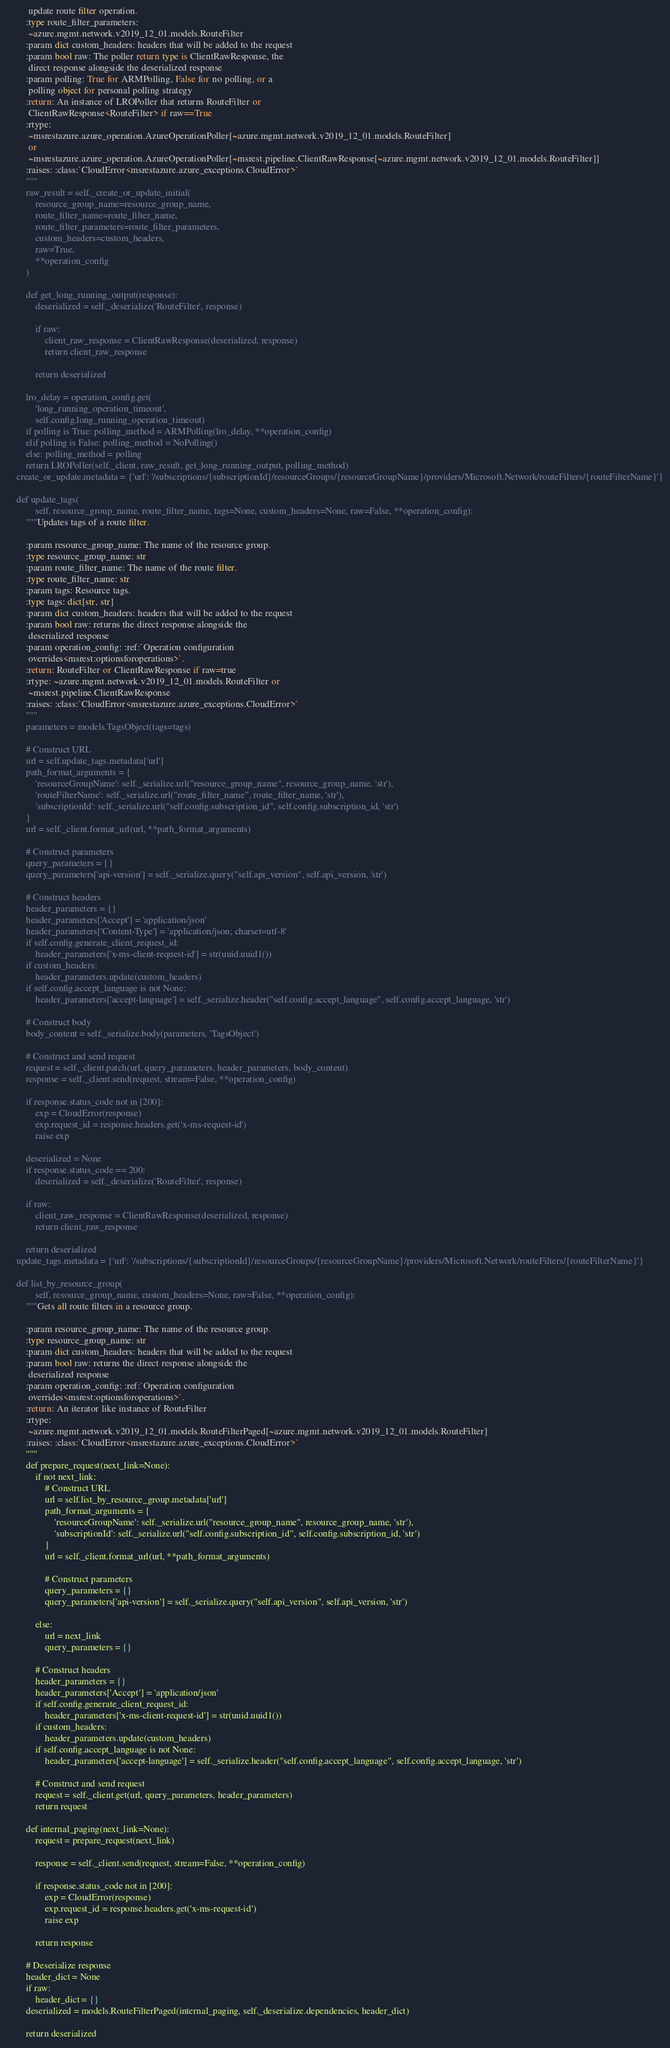<code> <loc_0><loc_0><loc_500><loc_500><_Python_>         update route filter operation.
        :type route_filter_parameters:
         ~azure.mgmt.network.v2019_12_01.models.RouteFilter
        :param dict custom_headers: headers that will be added to the request
        :param bool raw: The poller return type is ClientRawResponse, the
         direct response alongside the deserialized response
        :param polling: True for ARMPolling, False for no polling, or a
         polling object for personal polling strategy
        :return: An instance of LROPoller that returns RouteFilter or
         ClientRawResponse<RouteFilter> if raw==True
        :rtype:
         ~msrestazure.azure_operation.AzureOperationPoller[~azure.mgmt.network.v2019_12_01.models.RouteFilter]
         or
         ~msrestazure.azure_operation.AzureOperationPoller[~msrest.pipeline.ClientRawResponse[~azure.mgmt.network.v2019_12_01.models.RouteFilter]]
        :raises: :class:`CloudError<msrestazure.azure_exceptions.CloudError>`
        """
        raw_result = self._create_or_update_initial(
            resource_group_name=resource_group_name,
            route_filter_name=route_filter_name,
            route_filter_parameters=route_filter_parameters,
            custom_headers=custom_headers,
            raw=True,
            **operation_config
        )

        def get_long_running_output(response):
            deserialized = self._deserialize('RouteFilter', response)

            if raw:
                client_raw_response = ClientRawResponse(deserialized, response)
                return client_raw_response

            return deserialized

        lro_delay = operation_config.get(
            'long_running_operation_timeout',
            self.config.long_running_operation_timeout)
        if polling is True: polling_method = ARMPolling(lro_delay, **operation_config)
        elif polling is False: polling_method = NoPolling()
        else: polling_method = polling
        return LROPoller(self._client, raw_result, get_long_running_output, polling_method)
    create_or_update.metadata = {'url': '/subscriptions/{subscriptionId}/resourceGroups/{resourceGroupName}/providers/Microsoft.Network/routeFilters/{routeFilterName}'}

    def update_tags(
            self, resource_group_name, route_filter_name, tags=None, custom_headers=None, raw=False, **operation_config):
        """Updates tags of a route filter.

        :param resource_group_name: The name of the resource group.
        :type resource_group_name: str
        :param route_filter_name: The name of the route filter.
        :type route_filter_name: str
        :param tags: Resource tags.
        :type tags: dict[str, str]
        :param dict custom_headers: headers that will be added to the request
        :param bool raw: returns the direct response alongside the
         deserialized response
        :param operation_config: :ref:`Operation configuration
         overrides<msrest:optionsforoperations>`.
        :return: RouteFilter or ClientRawResponse if raw=true
        :rtype: ~azure.mgmt.network.v2019_12_01.models.RouteFilter or
         ~msrest.pipeline.ClientRawResponse
        :raises: :class:`CloudError<msrestazure.azure_exceptions.CloudError>`
        """
        parameters = models.TagsObject(tags=tags)

        # Construct URL
        url = self.update_tags.metadata['url']
        path_format_arguments = {
            'resourceGroupName': self._serialize.url("resource_group_name", resource_group_name, 'str'),
            'routeFilterName': self._serialize.url("route_filter_name", route_filter_name, 'str'),
            'subscriptionId': self._serialize.url("self.config.subscription_id", self.config.subscription_id, 'str')
        }
        url = self._client.format_url(url, **path_format_arguments)

        # Construct parameters
        query_parameters = {}
        query_parameters['api-version'] = self._serialize.query("self.api_version", self.api_version, 'str')

        # Construct headers
        header_parameters = {}
        header_parameters['Accept'] = 'application/json'
        header_parameters['Content-Type'] = 'application/json; charset=utf-8'
        if self.config.generate_client_request_id:
            header_parameters['x-ms-client-request-id'] = str(uuid.uuid1())
        if custom_headers:
            header_parameters.update(custom_headers)
        if self.config.accept_language is not None:
            header_parameters['accept-language'] = self._serialize.header("self.config.accept_language", self.config.accept_language, 'str')

        # Construct body
        body_content = self._serialize.body(parameters, 'TagsObject')

        # Construct and send request
        request = self._client.patch(url, query_parameters, header_parameters, body_content)
        response = self._client.send(request, stream=False, **operation_config)

        if response.status_code not in [200]:
            exp = CloudError(response)
            exp.request_id = response.headers.get('x-ms-request-id')
            raise exp

        deserialized = None
        if response.status_code == 200:
            deserialized = self._deserialize('RouteFilter', response)

        if raw:
            client_raw_response = ClientRawResponse(deserialized, response)
            return client_raw_response

        return deserialized
    update_tags.metadata = {'url': '/subscriptions/{subscriptionId}/resourceGroups/{resourceGroupName}/providers/Microsoft.Network/routeFilters/{routeFilterName}'}

    def list_by_resource_group(
            self, resource_group_name, custom_headers=None, raw=False, **operation_config):
        """Gets all route filters in a resource group.

        :param resource_group_name: The name of the resource group.
        :type resource_group_name: str
        :param dict custom_headers: headers that will be added to the request
        :param bool raw: returns the direct response alongside the
         deserialized response
        :param operation_config: :ref:`Operation configuration
         overrides<msrest:optionsforoperations>`.
        :return: An iterator like instance of RouteFilter
        :rtype:
         ~azure.mgmt.network.v2019_12_01.models.RouteFilterPaged[~azure.mgmt.network.v2019_12_01.models.RouteFilter]
        :raises: :class:`CloudError<msrestazure.azure_exceptions.CloudError>`
        """
        def prepare_request(next_link=None):
            if not next_link:
                # Construct URL
                url = self.list_by_resource_group.metadata['url']
                path_format_arguments = {
                    'resourceGroupName': self._serialize.url("resource_group_name", resource_group_name, 'str'),
                    'subscriptionId': self._serialize.url("self.config.subscription_id", self.config.subscription_id, 'str')
                }
                url = self._client.format_url(url, **path_format_arguments)

                # Construct parameters
                query_parameters = {}
                query_parameters['api-version'] = self._serialize.query("self.api_version", self.api_version, 'str')

            else:
                url = next_link
                query_parameters = {}

            # Construct headers
            header_parameters = {}
            header_parameters['Accept'] = 'application/json'
            if self.config.generate_client_request_id:
                header_parameters['x-ms-client-request-id'] = str(uuid.uuid1())
            if custom_headers:
                header_parameters.update(custom_headers)
            if self.config.accept_language is not None:
                header_parameters['accept-language'] = self._serialize.header("self.config.accept_language", self.config.accept_language, 'str')

            # Construct and send request
            request = self._client.get(url, query_parameters, header_parameters)
            return request

        def internal_paging(next_link=None):
            request = prepare_request(next_link)

            response = self._client.send(request, stream=False, **operation_config)

            if response.status_code not in [200]:
                exp = CloudError(response)
                exp.request_id = response.headers.get('x-ms-request-id')
                raise exp

            return response

        # Deserialize response
        header_dict = None
        if raw:
            header_dict = {}
        deserialized = models.RouteFilterPaged(internal_paging, self._deserialize.dependencies, header_dict)

        return deserialized</code> 